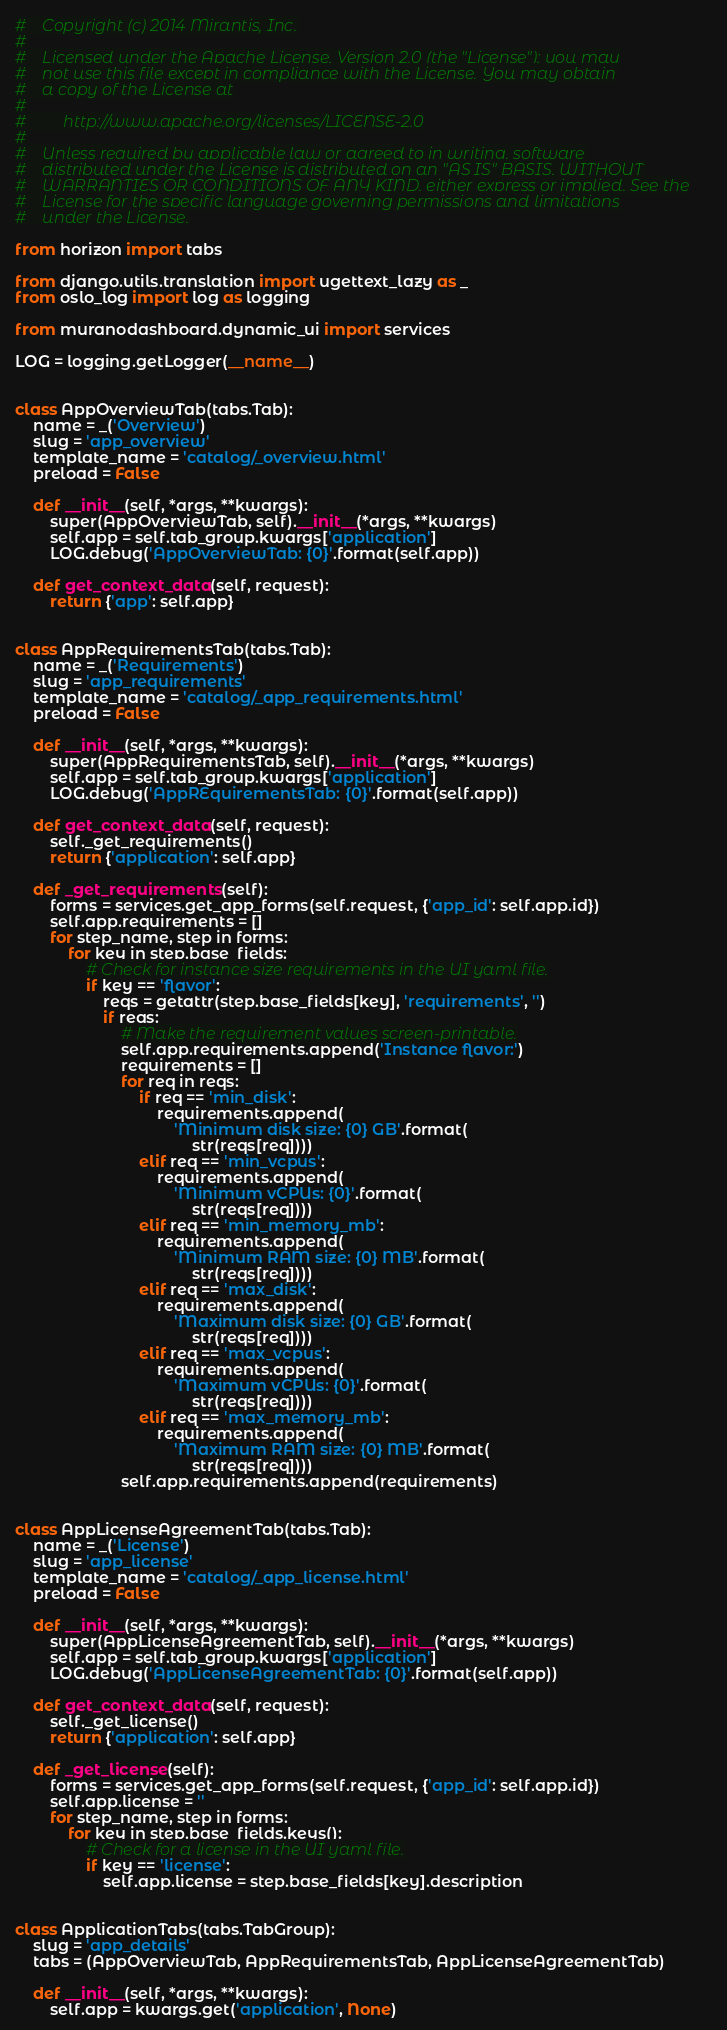Convert code to text. <code><loc_0><loc_0><loc_500><loc_500><_Python_>#    Copyright (c) 2014 Mirantis, Inc.
#
#    Licensed under the Apache License, Version 2.0 (the "License"); you may
#    not use this file except in compliance with the License. You may obtain
#    a copy of the License at
#
#         http://www.apache.org/licenses/LICENSE-2.0
#
#    Unless required by applicable law or agreed to in writing, software
#    distributed under the License is distributed on an "AS IS" BASIS, WITHOUT
#    WARRANTIES OR CONDITIONS OF ANY KIND, either express or implied. See the
#    License for the specific language governing permissions and limitations
#    under the License.

from horizon import tabs

from django.utils.translation import ugettext_lazy as _
from oslo_log import log as logging

from muranodashboard.dynamic_ui import services

LOG = logging.getLogger(__name__)


class AppOverviewTab(tabs.Tab):
    name = _('Overview')
    slug = 'app_overview'
    template_name = 'catalog/_overview.html'
    preload = False

    def __init__(self, *args, **kwargs):
        super(AppOverviewTab, self).__init__(*args, **kwargs)
        self.app = self.tab_group.kwargs['application']
        LOG.debug('AppOverviewTab: {0}'.format(self.app))

    def get_context_data(self, request):
        return {'app': self.app}


class AppRequirementsTab(tabs.Tab):
    name = _('Requirements')
    slug = 'app_requirements'
    template_name = 'catalog/_app_requirements.html'
    preload = False

    def __init__(self, *args, **kwargs):
        super(AppRequirementsTab, self).__init__(*args, **kwargs)
        self.app = self.tab_group.kwargs['application']
        LOG.debug('AppREquirementsTab: {0}'.format(self.app))

    def get_context_data(self, request):
        self._get_requirements()
        return {'application': self.app}

    def _get_requirements(self):
        forms = services.get_app_forms(self.request, {'app_id': self.app.id})
        self.app.requirements = []
        for step_name, step in forms:
            for key in step.base_fields:
                # Check for instance size requirements in the UI yaml file.
                if key == 'flavor':
                    reqs = getattr(step.base_fields[key], 'requirements', '')
                    if reqs:
                        # Make the requirement values screen-printable.
                        self.app.requirements.append('Instance flavor:')
                        requirements = []
                        for req in reqs:
                            if req == 'min_disk':
                                requirements.append(
                                    'Minimum disk size: {0} GB'.format(
                                        str(reqs[req])))
                            elif req == 'min_vcpus':
                                requirements.append(
                                    'Minimum vCPUs: {0}'.format(
                                        str(reqs[req])))
                            elif req == 'min_memory_mb':
                                requirements.append(
                                    'Minimum RAM size: {0} MB'.format(
                                        str(reqs[req])))
                            elif req == 'max_disk':
                                requirements.append(
                                    'Maximum disk size: {0} GB'.format(
                                        str(reqs[req])))
                            elif req == 'max_vcpus':
                                requirements.append(
                                    'Maximum vCPUs: {0}'.format(
                                        str(reqs[req])))
                            elif req == 'max_memory_mb':
                                requirements.append(
                                    'Maximum RAM size: {0} MB'.format(
                                        str(reqs[req])))
                        self.app.requirements.append(requirements)


class AppLicenseAgreementTab(tabs.Tab):
    name = _('License')
    slug = 'app_license'
    template_name = 'catalog/_app_license.html'
    preload = False

    def __init__(self, *args, **kwargs):
        super(AppLicenseAgreementTab, self).__init__(*args, **kwargs)
        self.app = self.tab_group.kwargs['application']
        LOG.debug('AppLicenseAgreementTab: {0}'.format(self.app))

    def get_context_data(self, request):
        self._get_license()
        return {'application': self.app}

    def _get_license(self):
        forms = services.get_app_forms(self.request, {'app_id': self.app.id})
        self.app.license = ''
        for step_name, step in forms:
            for key in step.base_fields.keys():
                # Check for a license in the UI yaml file.
                if key == 'license':
                    self.app.license = step.base_fields[key].description


class ApplicationTabs(tabs.TabGroup):
    slug = 'app_details'
    tabs = (AppOverviewTab, AppRequirementsTab, AppLicenseAgreementTab)

    def __init__(self, *args, **kwargs):
        self.app = kwargs.get('application', None)</code> 